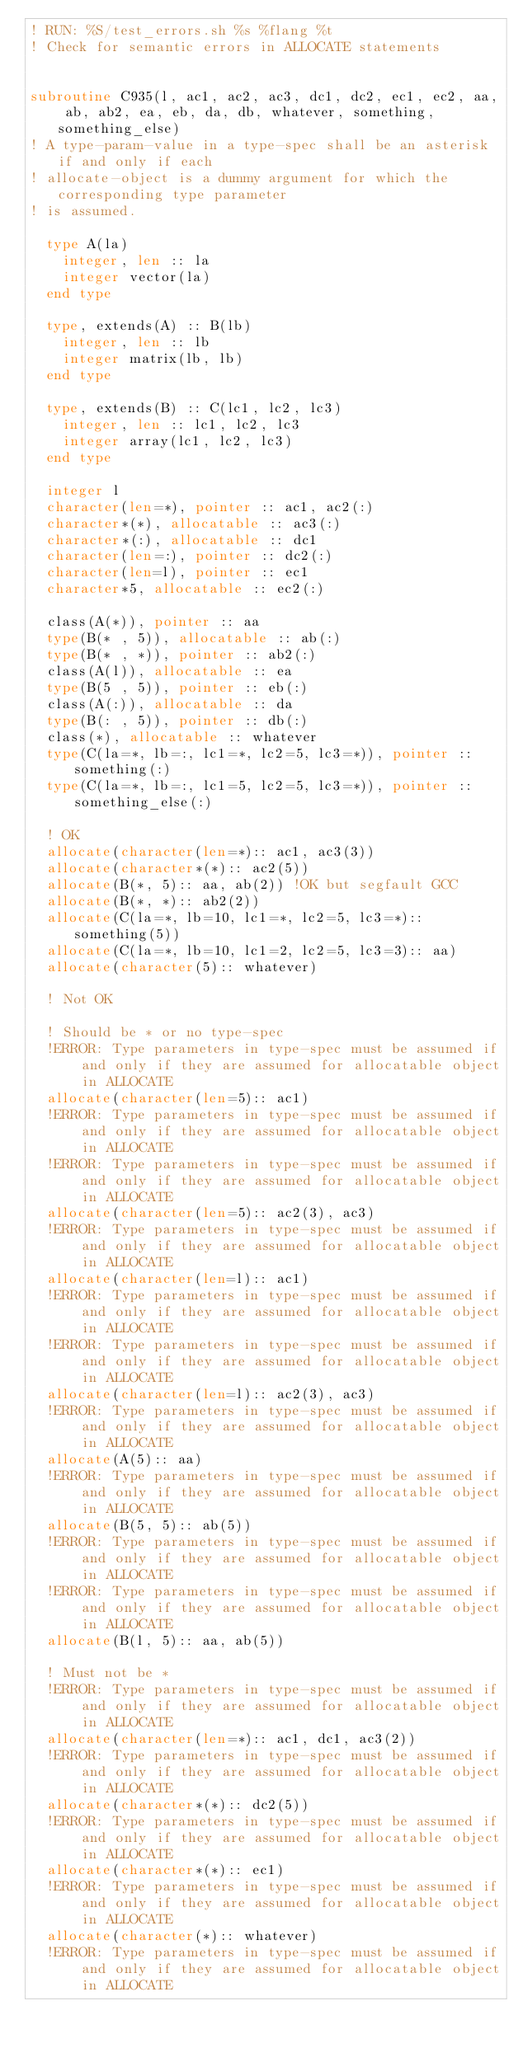Convert code to text. <code><loc_0><loc_0><loc_500><loc_500><_FORTRAN_>! RUN: %S/test_errors.sh %s %flang %t
! Check for semantic errors in ALLOCATE statements


subroutine C935(l, ac1, ac2, ac3, dc1, dc2, ec1, ec2, aa, ab, ab2, ea, eb, da, db, whatever, something, something_else)
! A type-param-value in a type-spec shall be an asterisk if and only if each
! allocate-object is a dummy argument for which the corresponding type parameter
! is assumed.

  type A(la)
    integer, len :: la
    integer vector(la)
  end type

  type, extends(A) :: B(lb)
    integer, len :: lb
    integer matrix(lb, lb)
  end type

  type, extends(B) :: C(lc1, lc2, lc3)
    integer, len :: lc1, lc2, lc3
    integer array(lc1, lc2, lc3)
  end type

  integer l
  character(len=*), pointer :: ac1, ac2(:)
  character*(*), allocatable :: ac3(:)
  character*(:), allocatable :: dc1
  character(len=:), pointer :: dc2(:)
  character(len=l), pointer :: ec1
  character*5, allocatable :: ec2(:)

  class(A(*)), pointer :: aa
  type(B(* , 5)), allocatable :: ab(:)
  type(B(* , *)), pointer :: ab2(:)
  class(A(l)), allocatable :: ea
  type(B(5 , 5)), pointer :: eb(:)
  class(A(:)), allocatable :: da
  type(B(: , 5)), pointer :: db(:)
  class(*), allocatable :: whatever
  type(C(la=*, lb=:, lc1=*, lc2=5, lc3=*)), pointer :: something(:)
  type(C(la=*, lb=:, lc1=5, lc2=5, lc3=*)), pointer :: something_else(:)

  ! OK
  allocate(character(len=*):: ac1, ac3(3))
  allocate(character*(*):: ac2(5))
  allocate(B(*, 5):: aa, ab(2)) !OK but segfault GCC
  allocate(B(*, *):: ab2(2))
  allocate(C(la=*, lb=10, lc1=*, lc2=5, lc3=*):: something(5))
  allocate(C(la=*, lb=10, lc1=2, lc2=5, lc3=3):: aa)
  allocate(character(5):: whatever)

  ! Not OK

  ! Should be * or no type-spec
  !ERROR: Type parameters in type-spec must be assumed if and only if they are assumed for allocatable object in ALLOCATE
  allocate(character(len=5):: ac1)
  !ERROR: Type parameters in type-spec must be assumed if and only if they are assumed for allocatable object in ALLOCATE
  !ERROR: Type parameters in type-spec must be assumed if and only if they are assumed for allocatable object in ALLOCATE
  allocate(character(len=5):: ac2(3), ac3)
  !ERROR: Type parameters in type-spec must be assumed if and only if they are assumed for allocatable object in ALLOCATE
  allocate(character(len=l):: ac1)
  !ERROR: Type parameters in type-spec must be assumed if and only if they are assumed for allocatable object in ALLOCATE
  !ERROR: Type parameters in type-spec must be assumed if and only if they are assumed for allocatable object in ALLOCATE
  allocate(character(len=l):: ac2(3), ac3)
  !ERROR: Type parameters in type-spec must be assumed if and only if they are assumed for allocatable object in ALLOCATE
  allocate(A(5):: aa)
  !ERROR: Type parameters in type-spec must be assumed if and only if they are assumed for allocatable object in ALLOCATE
  allocate(B(5, 5):: ab(5))
  !ERROR: Type parameters in type-spec must be assumed if and only if they are assumed for allocatable object in ALLOCATE
  !ERROR: Type parameters in type-spec must be assumed if and only if they are assumed for allocatable object in ALLOCATE
  allocate(B(l, 5):: aa, ab(5))

  ! Must not be *
  !ERROR: Type parameters in type-spec must be assumed if and only if they are assumed for allocatable object in ALLOCATE
  allocate(character(len=*):: ac1, dc1, ac3(2))
  !ERROR: Type parameters in type-spec must be assumed if and only if they are assumed for allocatable object in ALLOCATE
  allocate(character*(*):: dc2(5))
  !ERROR: Type parameters in type-spec must be assumed if and only if they are assumed for allocatable object in ALLOCATE
  allocate(character*(*):: ec1)
  !ERROR: Type parameters in type-spec must be assumed if and only if they are assumed for allocatable object in ALLOCATE
  allocate(character(*):: whatever)
  !ERROR: Type parameters in type-spec must be assumed if and only if they are assumed for allocatable object in ALLOCATE</code> 